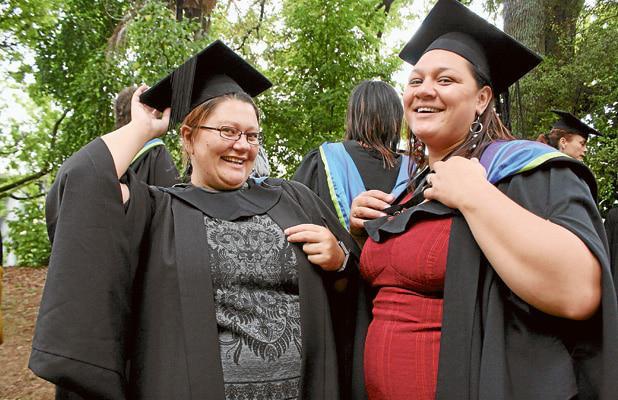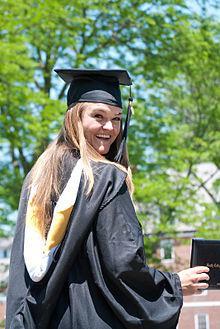The first image is the image on the left, the second image is the image on the right. Considering the images on both sides, is "Each image focuses on two smiling graduates wearing black gowns and mortarboards with a tassel hanging from each." valid? Answer yes or no. No. The first image is the image on the left, the second image is the image on the right. For the images shown, is this caption "An image shows a nonwhite male graduate standing on the left and a white female standing on the right." true? Answer yes or no. No. 